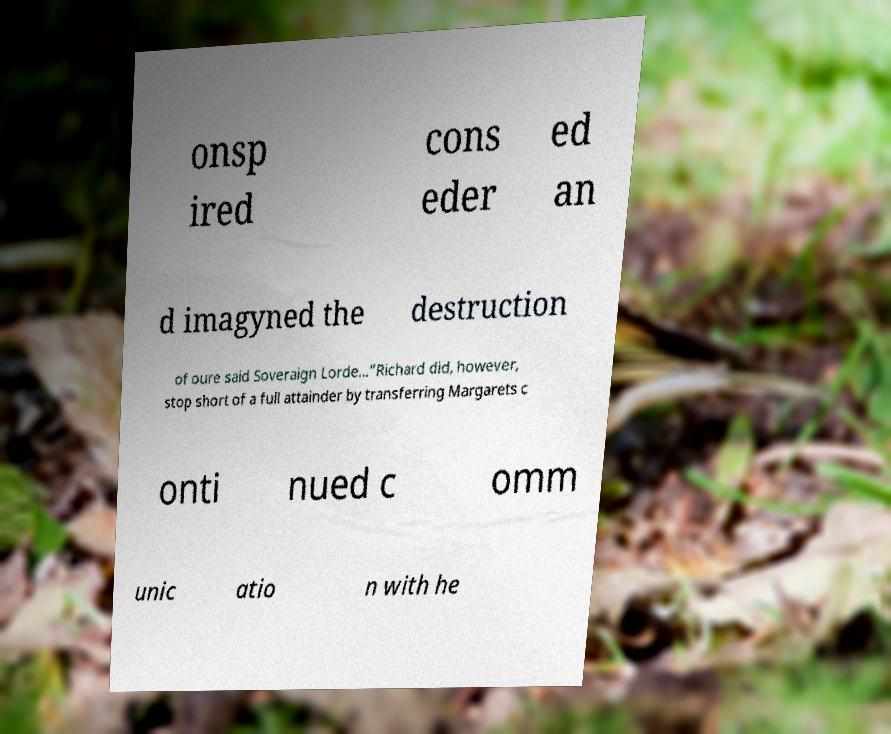Can you accurately transcribe the text from the provided image for me? onsp ired cons eder ed an d imagyned the destruction of oure said Soveraign Lorde...”Richard did, however, stop short of a full attainder by transferring Margarets c onti nued c omm unic atio n with he 